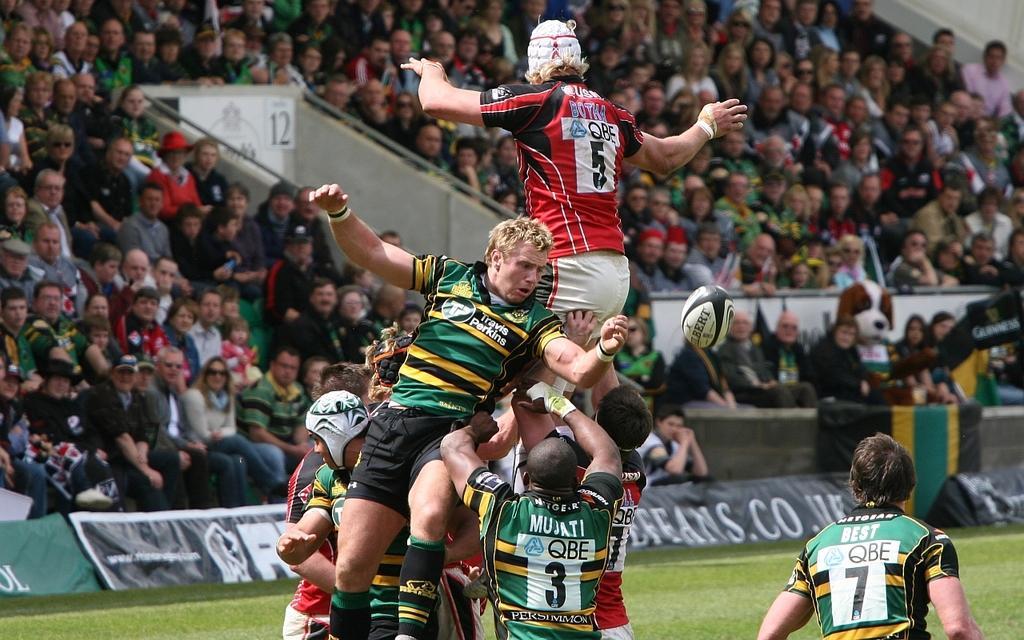Could you give a brief overview of what you see in this image? In this image there are group of persons. In the front persons are playing a game. In the background there are persons sitting and watching the game and there is a ball in the air. There are banners with some text written on it. On the ground there is grass. 